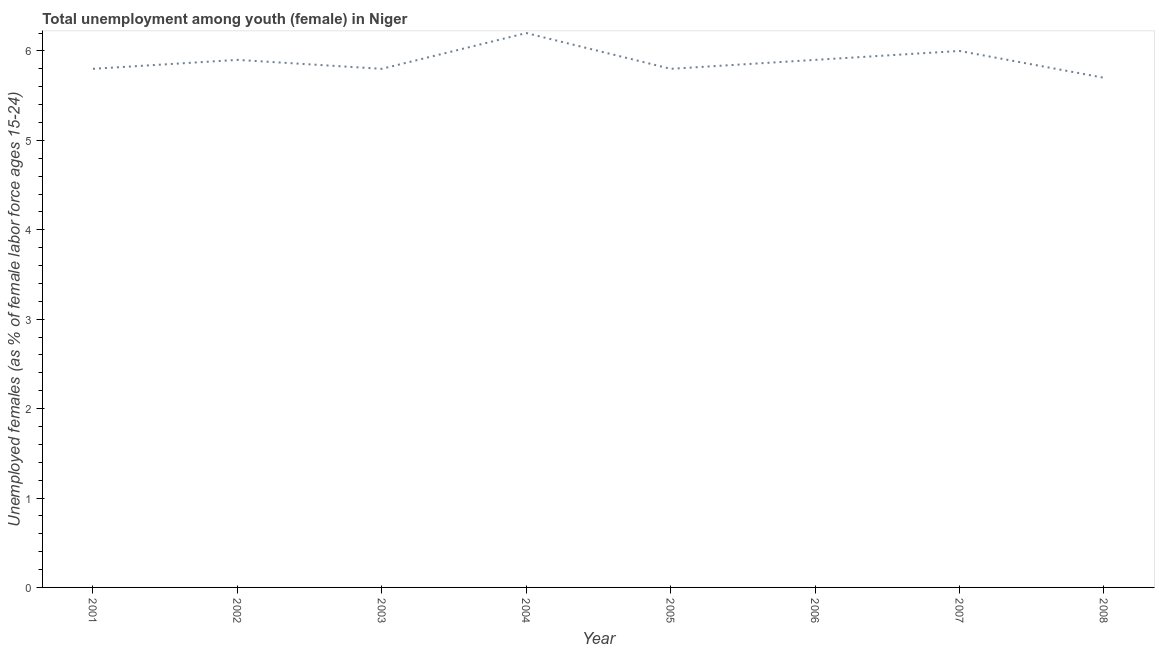What is the unemployed female youth population in 2007?
Your answer should be very brief. 6. Across all years, what is the maximum unemployed female youth population?
Offer a very short reply. 6.2. Across all years, what is the minimum unemployed female youth population?
Your answer should be compact. 5.7. What is the sum of the unemployed female youth population?
Your answer should be very brief. 47.1. What is the difference between the unemployed female youth population in 2004 and 2007?
Provide a succinct answer. 0.2. What is the average unemployed female youth population per year?
Give a very brief answer. 5.89. What is the median unemployed female youth population?
Offer a terse response. 5.85. Do a majority of the years between 2003 and 2005 (inclusive) have unemployed female youth population greater than 5.6 %?
Provide a succinct answer. Yes. What is the ratio of the unemployed female youth population in 2001 to that in 2006?
Offer a terse response. 0.98. What is the difference between the highest and the second highest unemployed female youth population?
Keep it short and to the point. 0.2. Is the sum of the unemployed female youth population in 2001 and 2006 greater than the maximum unemployed female youth population across all years?
Offer a terse response. Yes. In how many years, is the unemployed female youth population greater than the average unemployed female youth population taken over all years?
Provide a short and direct response. 4. How many lines are there?
Offer a terse response. 1. What is the difference between two consecutive major ticks on the Y-axis?
Keep it short and to the point. 1. Does the graph contain grids?
Provide a succinct answer. No. What is the title of the graph?
Keep it short and to the point. Total unemployment among youth (female) in Niger. What is the label or title of the X-axis?
Offer a terse response. Year. What is the label or title of the Y-axis?
Provide a succinct answer. Unemployed females (as % of female labor force ages 15-24). What is the Unemployed females (as % of female labor force ages 15-24) in 2001?
Offer a terse response. 5.8. What is the Unemployed females (as % of female labor force ages 15-24) in 2002?
Your answer should be compact. 5.9. What is the Unemployed females (as % of female labor force ages 15-24) of 2003?
Provide a short and direct response. 5.8. What is the Unemployed females (as % of female labor force ages 15-24) in 2004?
Your answer should be compact. 6.2. What is the Unemployed females (as % of female labor force ages 15-24) in 2005?
Make the answer very short. 5.8. What is the Unemployed females (as % of female labor force ages 15-24) of 2006?
Provide a succinct answer. 5.9. What is the Unemployed females (as % of female labor force ages 15-24) in 2008?
Provide a succinct answer. 5.7. What is the difference between the Unemployed females (as % of female labor force ages 15-24) in 2001 and 2002?
Your answer should be compact. -0.1. What is the difference between the Unemployed females (as % of female labor force ages 15-24) in 2001 and 2003?
Provide a short and direct response. 0. What is the difference between the Unemployed females (as % of female labor force ages 15-24) in 2001 and 2005?
Provide a succinct answer. 0. What is the difference between the Unemployed females (as % of female labor force ages 15-24) in 2002 and 2004?
Provide a short and direct response. -0.3. What is the difference between the Unemployed females (as % of female labor force ages 15-24) in 2002 and 2005?
Your answer should be very brief. 0.1. What is the difference between the Unemployed females (as % of female labor force ages 15-24) in 2002 and 2007?
Provide a succinct answer. -0.1. What is the difference between the Unemployed females (as % of female labor force ages 15-24) in 2002 and 2008?
Provide a succinct answer. 0.2. What is the difference between the Unemployed females (as % of female labor force ages 15-24) in 2003 and 2006?
Your answer should be compact. -0.1. What is the difference between the Unemployed females (as % of female labor force ages 15-24) in 2003 and 2007?
Ensure brevity in your answer.  -0.2. What is the difference between the Unemployed females (as % of female labor force ages 15-24) in 2004 and 2006?
Your answer should be very brief. 0.3. What is the difference between the Unemployed females (as % of female labor force ages 15-24) in 2005 and 2007?
Keep it short and to the point. -0.2. What is the difference between the Unemployed females (as % of female labor force ages 15-24) in 2005 and 2008?
Provide a short and direct response. 0.1. What is the difference between the Unemployed females (as % of female labor force ages 15-24) in 2006 and 2008?
Your answer should be very brief. 0.2. What is the ratio of the Unemployed females (as % of female labor force ages 15-24) in 2001 to that in 2002?
Ensure brevity in your answer.  0.98. What is the ratio of the Unemployed females (as % of female labor force ages 15-24) in 2001 to that in 2003?
Provide a short and direct response. 1. What is the ratio of the Unemployed females (as % of female labor force ages 15-24) in 2001 to that in 2004?
Provide a succinct answer. 0.94. What is the ratio of the Unemployed females (as % of female labor force ages 15-24) in 2001 to that in 2005?
Offer a very short reply. 1. What is the ratio of the Unemployed females (as % of female labor force ages 15-24) in 2001 to that in 2006?
Provide a succinct answer. 0.98. What is the ratio of the Unemployed females (as % of female labor force ages 15-24) in 2001 to that in 2007?
Offer a very short reply. 0.97. What is the ratio of the Unemployed females (as % of female labor force ages 15-24) in 2001 to that in 2008?
Offer a very short reply. 1.02. What is the ratio of the Unemployed females (as % of female labor force ages 15-24) in 2002 to that in 2003?
Ensure brevity in your answer.  1.02. What is the ratio of the Unemployed females (as % of female labor force ages 15-24) in 2002 to that in 2004?
Make the answer very short. 0.95. What is the ratio of the Unemployed females (as % of female labor force ages 15-24) in 2002 to that in 2006?
Provide a succinct answer. 1. What is the ratio of the Unemployed females (as % of female labor force ages 15-24) in 2002 to that in 2007?
Provide a succinct answer. 0.98. What is the ratio of the Unemployed females (as % of female labor force ages 15-24) in 2002 to that in 2008?
Offer a very short reply. 1.03. What is the ratio of the Unemployed females (as % of female labor force ages 15-24) in 2003 to that in 2004?
Provide a succinct answer. 0.94. What is the ratio of the Unemployed females (as % of female labor force ages 15-24) in 2004 to that in 2005?
Provide a succinct answer. 1.07. What is the ratio of the Unemployed females (as % of female labor force ages 15-24) in 2004 to that in 2006?
Offer a terse response. 1.05. What is the ratio of the Unemployed females (as % of female labor force ages 15-24) in 2004 to that in 2007?
Provide a succinct answer. 1.03. What is the ratio of the Unemployed females (as % of female labor force ages 15-24) in 2004 to that in 2008?
Provide a short and direct response. 1.09. What is the ratio of the Unemployed females (as % of female labor force ages 15-24) in 2005 to that in 2006?
Provide a succinct answer. 0.98. What is the ratio of the Unemployed females (as % of female labor force ages 15-24) in 2005 to that in 2007?
Make the answer very short. 0.97. What is the ratio of the Unemployed females (as % of female labor force ages 15-24) in 2005 to that in 2008?
Offer a very short reply. 1.02. What is the ratio of the Unemployed females (as % of female labor force ages 15-24) in 2006 to that in 2008?
Your answer should be compact. 1.03. What is the ratio of the Unemployed females (as % of female labor force ages 15-24) in 2007 to that in 2008?
Your response must be concise. 1.05. 